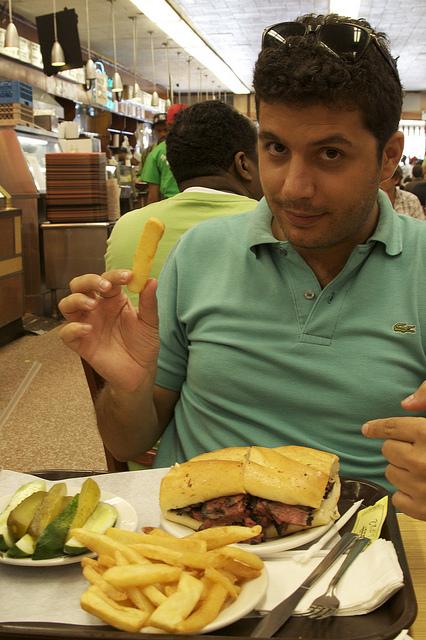Where are the men's sunglasses?
Keep it brief. Head. What is his sandwich made with?
Concise answer only. Meat. What is the man holding over his mouth?
Keep it brief. Fry. What color shirt is this person wearing?
Quick response, please. Green. Is the person wearing glasses?
Be succinct. Yes. Does the sandwich have lettuce?
Write a very short answer. No. What kind of silverware is on his plate?
Concise answer only. Fork and knife. What is the man eating?
Answer briefly. Sandwich. 